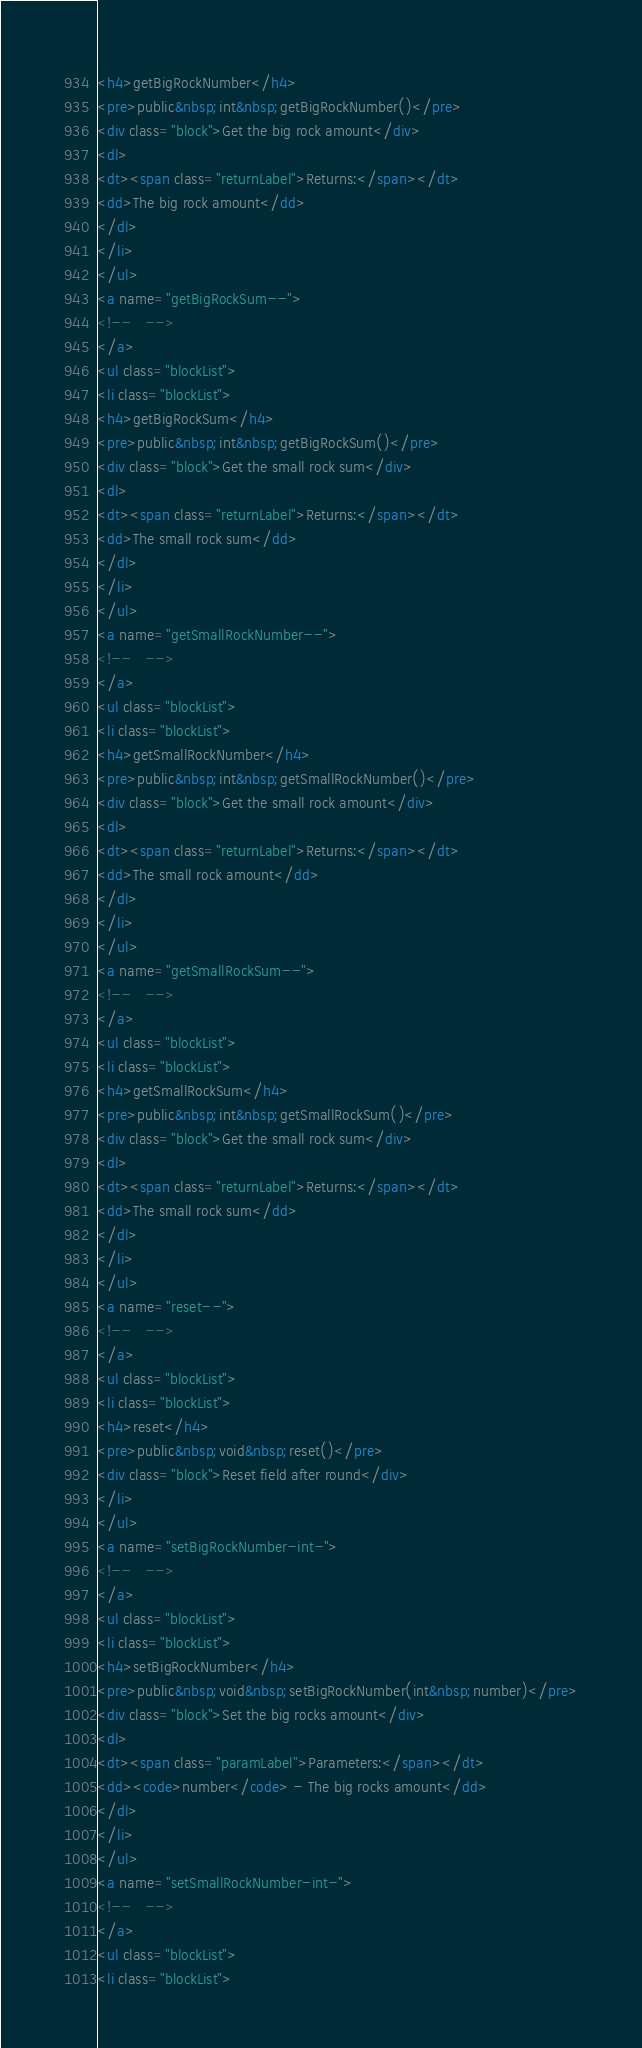Convert code to text. <code><loc_0><loc_0><loc_500><loc_500><_HTML_><h4>getBigRockNumber</h4>
<pre>public&nbsp;int&nbsp;getBigRockNumber()</pre>
<div class="block">Get the big rock amount</div>
<dl>
<dt><span class="returnLabel">Returns:</span></dt>
<dd>The big rock amount</dd>
</dl>
</li>
</ul>
<a name="getBigRockSum--">
<!--   -->
</a>
<ul class="blockList">
<li class="blockList">
<h4>getBigRockSum</h4>
<pre>public&nbsp;int&nbsp;getBigRockSum()</pre>
<div class="block">Get the small rock sum</div>
<dl>
<dt><span class="returnLabel">Returns:</span></dt>
<dd>The small rock sum</dd>
</dl>
</li>
</ul>
<a name="getSmallRockNumber--">
<!--   -->
</a>
<ul class="blockList">
<li class="blockList">
<h4>getSmallRockNumber</h4>
<pre>public&nbsp;int&nbsp;getSmallRockNumber()</pre>
<div class="block">Get the small rock amount</div>
<dl>
<dt><span class="returnLabel">Returns:</span></dt>
<dd>The small rock amount</dd>
</dl>
</li>
</ul>
<a name="getSmallRockSum--">
<!--   -->
</a>
<ul class="blockList">
<li class="blockList">
<h4>getSmallRockSum</h4>
<pre>public&nbsp;int&nbsp;getSmallRockSum()</pre>
<div class="block">Get the small rock sum</div>
<dl>
<dt><span class="returnLabel">Returns:</span></dt>
<dd>The small rock sum</dd>
</dl>
</li>
</ul>
<a name="reset--">
<!--   -->
</a>
<ul class="blockList">
<li class="blockList">
<h4>reset</h4>
<pre>public&nbsp;void&nbsp;reset()</pre>
<div class="block">Reset field after round</div>
</li>
</ul>
<a name="setBigRockNumber-int-">
<!--   -->
</a>
<ul class="blockList">
<li class="blockList">
<h4>setBigRockNumber</h4>
<pre>public&nbsp;void&nbsp;setBigRockNumber(int&nbsp;number)</pre>
<div class="block">Set the big rocks amount</div>
<dl>
<dt><span class="paramLabel">Parameters:</span></dt>
<dd><code>number</code> - The big rocks amount</dd>
</dl>
</li>
</ul>
<a name="setSmallRockNumber-int-">
<!--   -->
</a>
<ul class="blockList">
<li class="blockList"></code> 